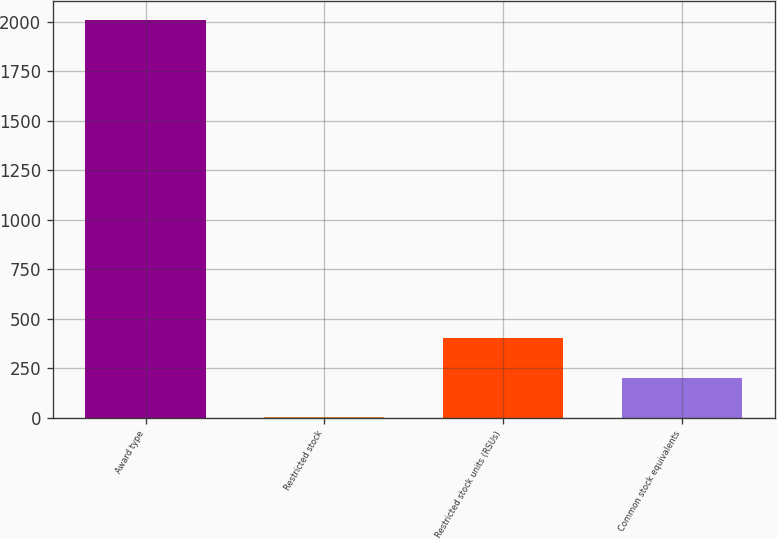<chart> <loc_0><loc_0><loc_500><loc_500><bar_chart><fcel>Award type<fcel>Restricted stock<fcel>Restricted stock units (RSUs)<fcel>Common stock equivalents<nl><fcel>2008<fcel>0.4<fcel>401.92<fcel>201.16<nl></chart> 